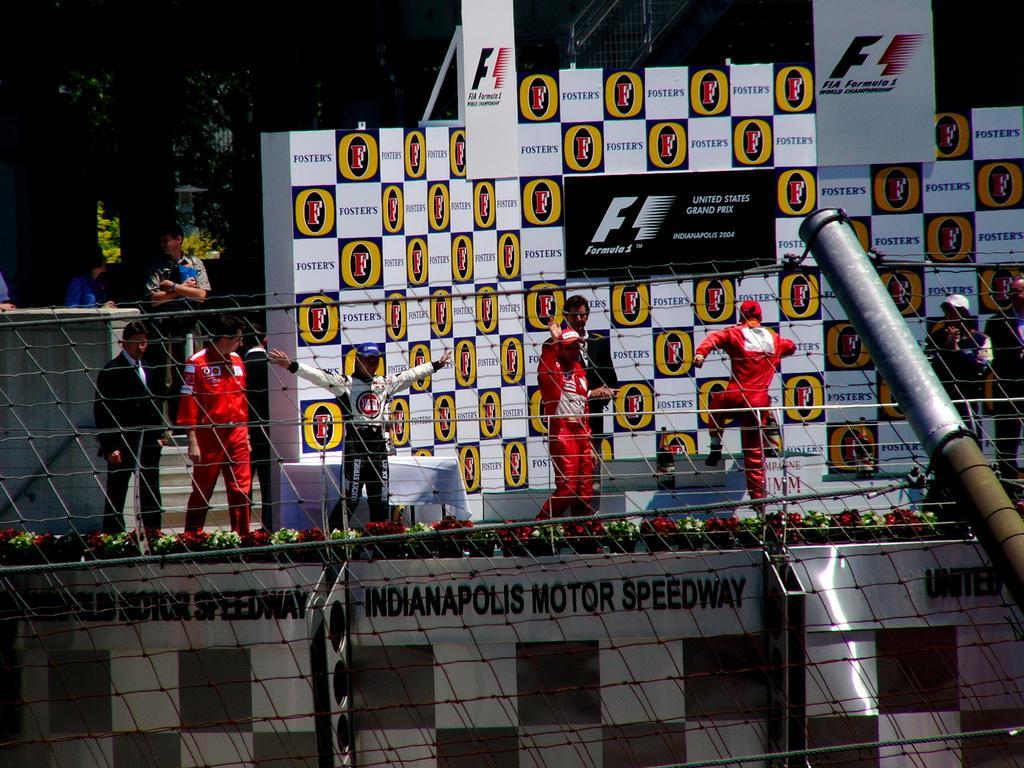Describe this image in one or two sentences. In the image in the center we can see one stage. On the stage,we can see few people were standing. And we can see banners,plant pots,flowers,fence and pole. In the background we can see trees and buildings. 